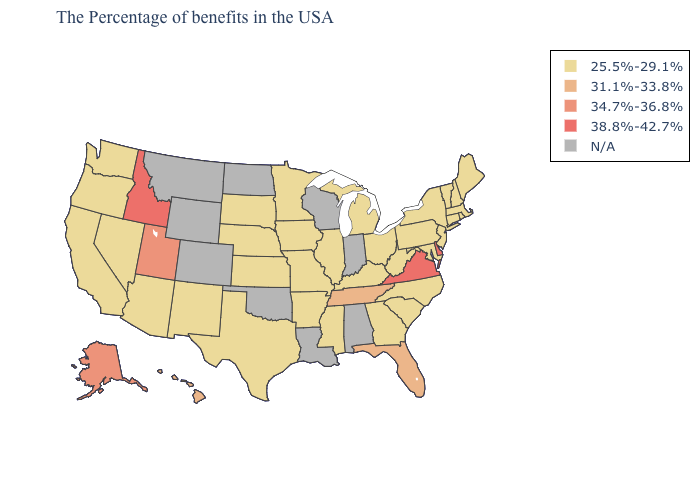What is the highest value in states that border North Carolina?
Quick response, please. 38.8%-42.7%. Which states hav the highest value in the West?
Concise answer only. Idaho. What is the value of Iowa?
Answer briefly. 25.5%-29.1%. Name the states that have a value in the range 38.8%-42.7%?
Answer briefly. Delaware, Virginia, Idaho. Does Delaware have the lowest value in the South?
Give a very brief answer. No. Name the states that have a value in the range 31.1%-33.8%?
Answer briefly. Florida, Tennessee, Hawaii. Name the states that have a value in the range 31.1%-33.8%?
Be succinct. Florida, Tennessee, Hawaii. What is the value of Louisiana?
Keep it brief. N/A. Does Delaware have the highest value in the USA?
Concise answer only. Yes. Name the states that have a value in the range 25.5%-29.1%?
Be succinct. Maine, Massachusetts, Rhode Island, New Hampshire, Vermont, Connecticut, New York, New Jersey, Maryland, Pennsylvania, North Carolina, South Carolina, West Virginia, Ohio, Georgia, Michigan, Kentucky, Illinois, Mississippi, Missouri, Arkansas, Minnesota, Iowa, Kansas, Nebraska, Texas, South Dakota, New Mexico, Arizona, Nevada, California, Washington, Oregon. What is the value of Delaware?
Concise answer only. 38.8%-42.7%. What is the value of North Dakota?
Answer briefly. N/A. What is the value of Ohio?
Keep it brief. 25.5%-29.1%. How many symbols are there in the legend?
Quick response, please. 5. 